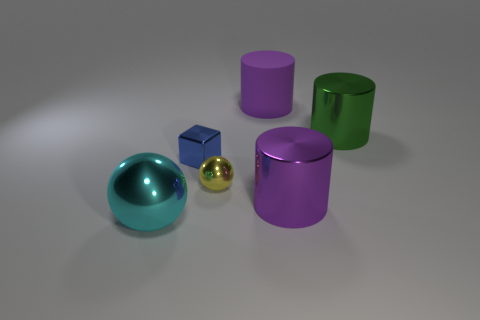What number of things are either tiny cyan matte spheres or small blue metal blocks?
Ensure brevity in your answer.  1. Are the cube behind the tiny yellow metallic sphere and the cylinder that is in front of the large green metal thing made of the same material?
Keep it short and to the point. Yes. What is the color of the large sphere that is made of the same material as the small blue object?
Give a very brief answer. Cyan. How many metal cubes have the same size as the yellow ball?
Provide a succinct answer. 1. How many other objects are the same color as the rubber thing?
Your answer should be compact. 1. Is the shape of the small shiny thing that is on the left side of the tiny ball the same as the purple object that is right of the big purple matte object?
Give a very brief answer. No. There is a yellow thing that is the same size as the blue shiny cube; what is its shape?
Provide a succinct answer. Sphere. Are there an equal number of big green metal objects left of the large green metal thing and metal spheres that are behind the yellow shiny ball?
Your response must be concise. Yes. Are there any other things that have the same shape as the tiny blue object?
Your answer should be compact. No. Is the tiny yellow object that is in front of the cube made of the same material as the green cylinder?
Provide a succinct answer. Yes. 